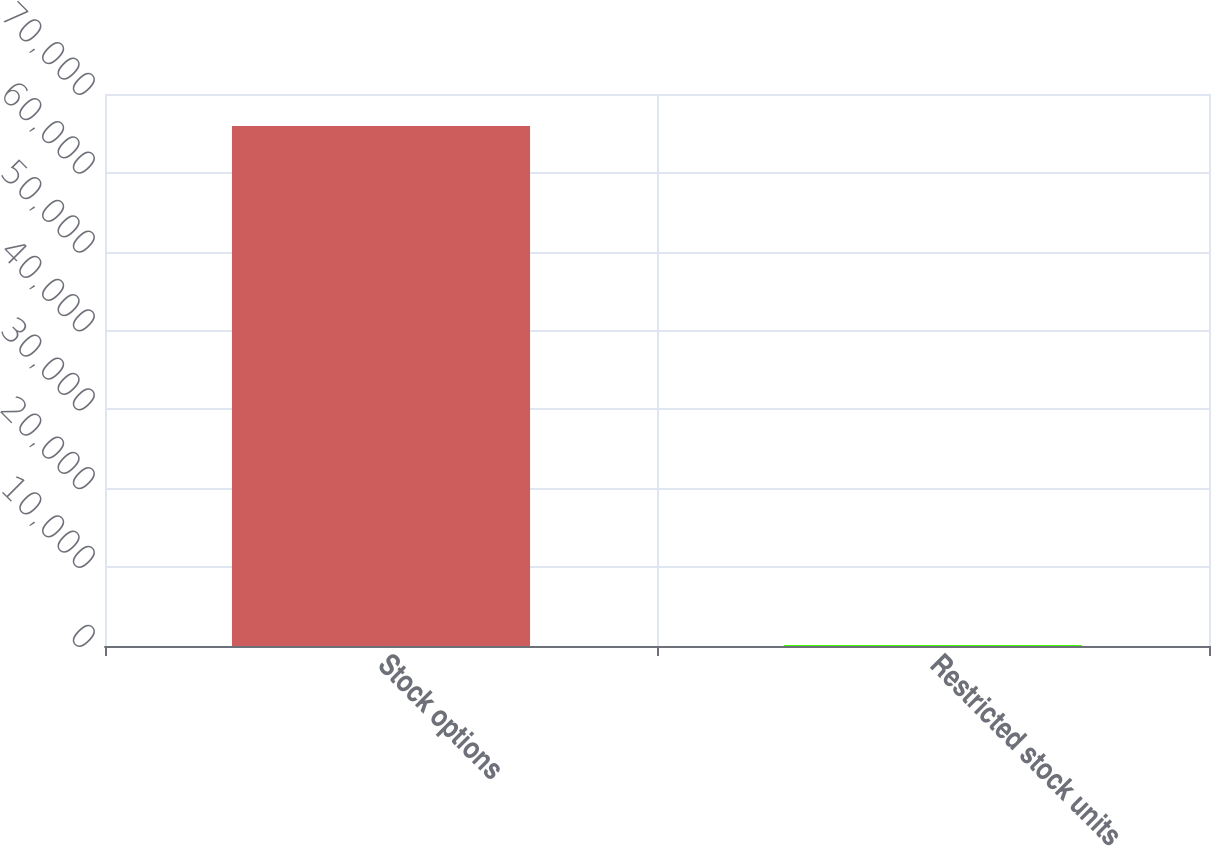Convert chart. <chart><loc_0><loc_0><loc_500><loc_500><bar_chart><fcel>Stock options<fcel>Restricted stock units<nl><fcel>65955<fcel>113<nl></chart> 